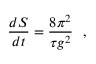<formula> <loc_0><loc_0><loc_500><loc_500>\frac { d S } { d t } = \frac { 8 \pi ^ { 2 } } { \tau g ^ { 2 } } ,</formula> 